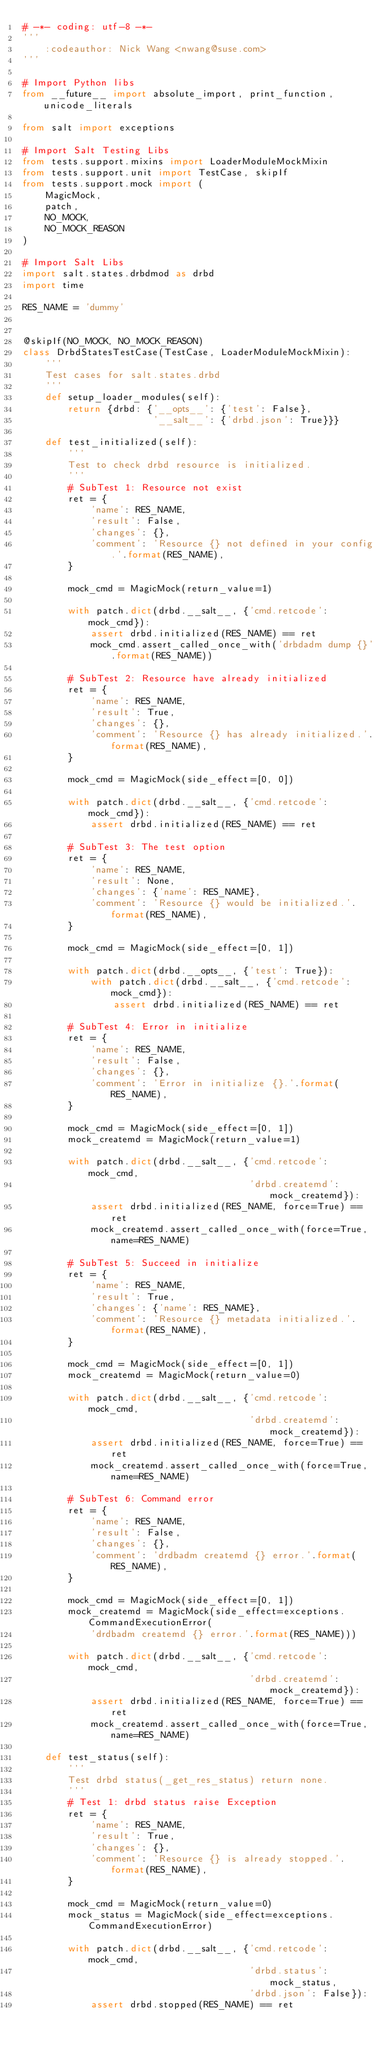<code> <loc_0><loc_0><loc_500><loc_500><_Python_># -*- coding: utf-8 -*-
'''
    :codeauthor: Nick Wang <nwang@suse.com>
'''

# Import Python libs
from __future__ import absolute_import, print_function, unicode_literals

from salt import exceptions

# Import Salt Testing Libs
from tests.support.mixins import LoaderModuleMockMixin
from tests.support.unit import TestCase, skipIf
from tests.support.mock import (
    MagicMock,
    patch,
    NO_MOCK,
    NO_MOCK_REASON
)

# Import Salt Libs
import salt.states.drbdmod as drbd
import time

RES_NAME = 'dummy'


@skipIf(NO_MOCK, NO_MOCK_REASON)
class DrbdStatesTestCase(TestCase, LoaderModuleMockMixin):
    '''
    Test cases for salt.states.drbd
    '''
    def setup_loader_modules(self):
        return {drbd: {'__opts__': {'test': False},
                       '__salt__': {'drbd.json': True}}}

    def test_initialized(self):
        '''
        Test to check drbd resource is initialized.
        '''
        # SubTest 1: Resource not exist
        ret = {
            'name': RES_NAME,
            'result': False,
            'changes': {},
            'comment': 'Resource {} not defined in your config.'.format(RES_NAME),
        }

        mock_cmd = MagicMock(return_value=1)

        with patch.dict(drbd.__salt__, {'cmd.retcode': mock_cmd}):
            assert drbd.initialized(RES_NAME) == ret
            mock_cmd.assert_called_once_with('drbdadm dump {}'.format(RES_NAME))

        # SubTest 2: Resource have already initialized
        ret = {
            'name': RES_NAME,
            'result': True,
            'changes': {},
            'comment': 'Resource {} has already initialized.'.format(RES_NAME),
        }

        mock_cmd = MagicMock(side_effect=[0, 0])

        with patch.dict(drbd.__salt__, {'cmd.retcode': mock_cmd}):
            assert drbd.initialized(RES_NAME) == ret

        # SubTest 3: The test option
        ret = {
            'name': RES_NAME,
            'result': None,
            'changes': {'name': RES_NAME},
            'comment': 'Resource {} would be initialized.'.format(RES_NAME),
        }

        mock_cmd = MagicMock(side_effect=[0, 1])

        with patch.dict(drbd.__opts__, {'test': True}):
            with patch.dict(drbd.__salt__, {'cmd.retcode': mock_cmd}):
                assert drbd.initialized(RES_NAME) == ret

        # SubTest 4: Error in initialize
        ret = {
            'name': RES_NAME,
            'result': False,
            'changes': {},
            'comment': 'Error in initialize {}.'.format(RES_NAME),
        }

        mock_cmd = MagicMock(side_effect=[0, 1])
        mock_createmd = MagicMock(return_value=1)

        with patch.dict(drbd.__salt__, {'cmd.retcode': mock_cmd,
                                        'drbd.createmd': mock_createmd}):
            assert drbd.initialized(RES_NAME, force=True) == ret
            mock_createmd.assert_called_once_with(force=True, name=RES_NAME)

        # SubTest 5: Succeed in initialize
        ret = {
            'name': RES_NAME,
            'result': True,
            'changes': {'name': RES_NAME},
            'comment': 'Resource {} metadata initialized.'.format(RES_NAME),
        }

        mock_cmd = MagicMock(side_effect=[0, 1])
        mock_createmd = MagicMock(return_value=0)

        with patch.dict(drbd.__salt__, {'cmd.retcode': mock_cmd,
                                        'drbd.createmd': mock_createmd}):
            assert drbd.initialized(RES_NAME, force=True) == ret
            mock_createmd.assert_called_once_with(force=True, name=RES_NAME)

        # SubTest 6: Command error
        ret = {
            'name': RES_NAME,
            'result': False,
            'changes': {},
            'comment': 'drdbadm createmd {} error.'.format(RES_NAME),
        }

        mock_cmd = MagicMock(side_effect=[0, 1])
        mock_createmd = MagicMock(side_effect=exceptions.CommandExecutionError(
            'drdbadm createmd {} error.'.format(RES_NAME)))

        with patch.dict(drbd.__salt__, {'cmd.retcode': mock_cmd,
                                        'drbd.createmd': mock_createmd}):
            assert drbd.initialized(RES_NAME, force=True) == ret
            mock_createmd.assert_called_once_with(force=True, name=RES_NAME)

    def test_status(self):
        '''
        Test drbd status(_get_res_status) return none.
        '''
        # Test 1: drbd status raise Exception
        ret = {
            'name': RES_NAME,
            'result': True,
            'changes': {},
            'comment': 'Resource {} is already stopped.'.format(RES_NAME),
        }

        mock_cmd = MagicMock(return_value=0)
        mock_status = MagicMock(side_effect=exceptions.CommandExecutionError)

        with patch.dict(drbd.__salt__, {'cmd.retcode': mock_cmd,
                                        'drbd.status': mock_status,
                                        'drbd.json': False}):
            assert drbd.stopped(RES_NAME) == ret
</code> 